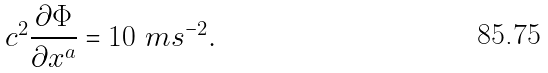Convert formula to latex. <formula><loc_0><loc_0><loc_500><loc_500>c ^ { 2 } \frac { \partial \Phi } { \partial x ^ { a } } = 1 0 \ m s ^ { - 2 } .</formula> 